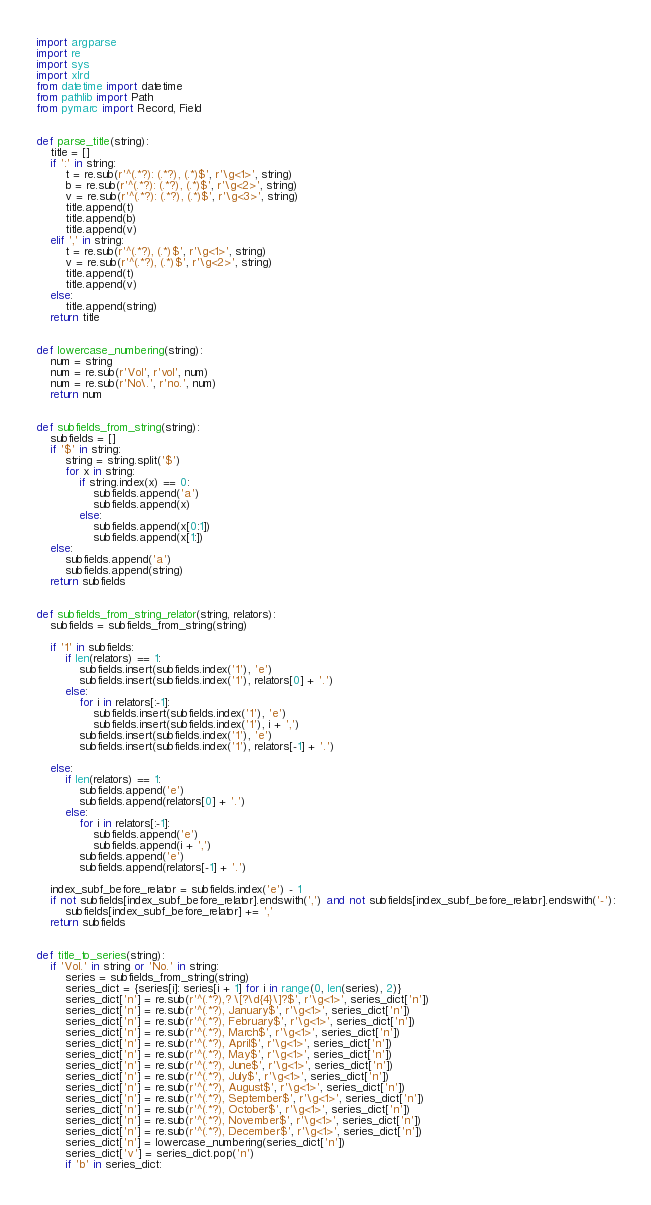Convert code to text. <code><loc_0><loc_0><loc_500><loc_500><_Python_>import argparse
import re
import sys
import xlrd
from datetime import datetime
from pathlib import Path
from pymarc import Record, Field


def parse_title(string):
    title = []
    if ':' in string:
        t = re.sub(r'^(.*?): (.*?), (.*)$', r'\g<1>', string)
        b = re.sub(r'^(.*?): (.*?), (.*)$', r'\g<2>', string)
        v = re.sub(r'^(.*?): (.*?), (.*)$', r'\g<3>', string)
        title.append(t)
        title.append(b)
        title.append(v)
    elif ',' in string:
        t = re.sub(r'^(.*?), (.*)$', r'\g<1>', string)
        v = re.sub(r'^(.*?), (.*)$', r'\g<2>', string)
        title.append(t)
        title.append(v)
    else:
        title.append(string)
    return title


def lowercase_numbering(string):
    num = string
    num = re.sub(r'Vol', r'vol', num)
    num = re.sub(r'No\.', r'no.', num)
    return num


def subfields_from_string(string):
    subfields = []
    if '$' in string:
        string = string.split('$')
        for x in string:
            if string.index(x) == 0:
                subfields.append('a')
                subfields.append(x)
            else:
                subfields.append(x[0:1])
                subfields.append(x[1:])
    else:
        subfields.append('a')
        subfields.append(string)
    return subfields


def subfields_from_string_relator(string, relators):
    subfields = subfields_from_string(string)
    
    if '1' in subfields:
        if len(relators) == 1:
            subfields.insert(subfields.index('1'), 'e')
            subfields.insert(subfields.index('1'), relators[0] + '.')
        else:
            for i in relators[:-1]:
                subfields.insert(subfields.index('1'), 'e')
                subfields.insert(subfields.index('1'), i + ',')
            subfields.insert(subfields.index('1'), 'e')
            subfields.insert(subfields.index('1'), relators[-1] + '.')
        
    else:
        if len(relators) == 1:
            subfields.append('e')
            subfields.append(relators[0] + '.')
        else:
            for i in relators[:-1]:
                subfields.append('e')
                subfields.append(i + ',')
            subfields.append('e')
            subfields.append(relators[-1] + '.')
    
    index_subf_before_relator = subfields.index('e') - 1
    if not subfields[index_subf_before_relator].endswith(',') and not subfields[index_subf_before_relator].endswith('-'):
        subfields[index_subf_before_relator] += ','
    return subfields


def title_to_series(string):
    if 'Vol.' in string or 'No.' in string:
        series = subfields_from_string(string)
        series_dict = {series[i]: series[i + 1] for i in range(0, len(series), 2)}
        series_dict['n'] = re.sub(r'^(.*?),? \[?\d{4}\]?$', r'\g<1>', series_dict['n'])
        series_dict['n'] = re.sub(r'^(.*?), January$', r'\g<1>', series_dict['n'])
        series_dict['n'] = re.sub(r'^(.*?), February$', r'\g<1>', series_dict['n'])
        series_dict['n'] = re.sub(r'^(.*?), March$', r'\g<1>', series_dict['n'])
        series_dict['n'] = re.sub(r'^(.*?), April$', r'\g<1>', series_dict['n'])
        series_dict['n'] = re.sub(r'^(.*?), May$', r'\g<1>', series_dict['n'])
        series_dict['n'] = re.sub(r'^(.*?), June$', r'\g<1>', series_dict['n'])
        series_dict['n'] = re.sub(r'^(.*?), July$', r'\g<1>', series_dict['n'])
        series_dict['n'] = re.sub(r'^(.*?), August$', r'\g<1>', series_dict['n'])
        series_dict['n'] = re.sub(r'^(.*?), September$', r'\g<1>', series_dict['n'])
        series_dict['n'] = re.sub(r'^(.*?), October$', r'\g<1>', series_dict['n'])
        series_dict['n'] = re.sub(r'^(.*?), November$', r'\g<1>', series_dict['n'])
        series_dict['n'] = re.sub(r'^(.*?), December$', r'\g<1>', series_dict['n'])
        series_dict['n'] = lowercase_numbering(series_dict['n'])
        series_dict['v'] = series_dict.pop('n')
        if 'b' in series_dict:</code> 